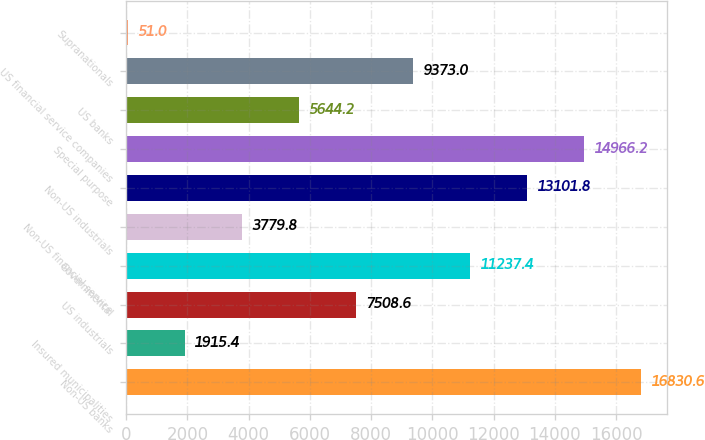Convert chart. <chart><loc_0><loc_0><loc_500><loc_500><bar_chart><fcel>Non-US banks<fcel>Insured municipalities<fcel>US industrials<fcel>Governmental<fcel>Non-US financial service<fcel>Non-US industrials<fcel>Special purpose<fcel>US banks<fcel>US financial service companies<fcel>Supranationals<nl><fcel>16830.6<fcel>1915.4<fcel>7508.6<fcel>11237.4<fcel>3779.8<fcel>13101.8<fcel>14966.2<fcel>5644.2<fcel>9373<fcel>51<nl></chart> 